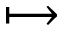<formula> <loc_0><loc_0><loc_500><loc_500>\longmapsto</formula> 